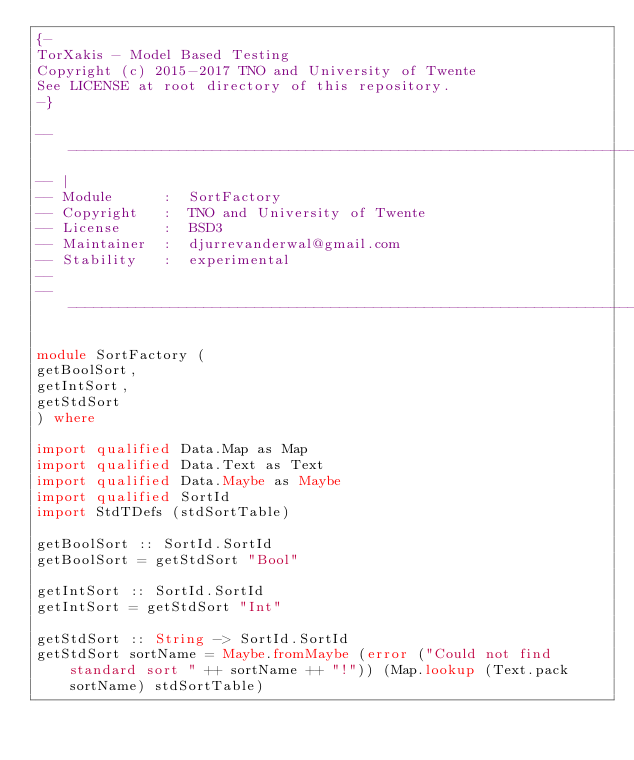<code> <loc_0><loc_0><loc_500><loc_500><_Haskell_>{-
TorXakis - Model Based Testing
Copyright (c) 2015-2017 TNO and University of Twente
See LICENSE at root directory of this repository.
-}

-----------------------------------------------------------------------------
-- |
-- Module      :  SortFactory
-- Copyright   :  TNO and University of Twente
-- License     :  BSD3
-- Maintainer  :  djurrevanderwal@gmail.com
-- Stability   :  experimental
--
-----------------------------------------------------------------------------

module SortFactory (
getBoolSort,
getIntSort,
getStdSort
) where

import qualified Data.Map as Map
import qualified Data.Text as Text
import qualified Data.Maybe as Maybe
import qualified SortId
import StdTDefs (stdSortTable)

getBoolSort :: SortId.SortId
getBoolSort = getStdSort "Bool"

getIntSort :: SortId.SortId
getIntSort = getStdSort "Int"

getStdSort :: String -> SortId.SortId
getStdSort sortName = Maybe.fromMaybe (error ("Could not find standard sort " ++ sortName ++ "!")) (Map.lookup (Text.pack sortName) stdSortTable)

</code> 